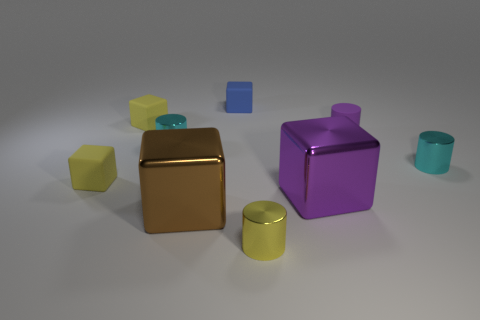What materials do the objects appear to be made of? The objects within the image appear to have a smooth, reflective surface, suggesting they could be made of materials such as plastic or polished metal, contributing to their sheen and substantial presence. 